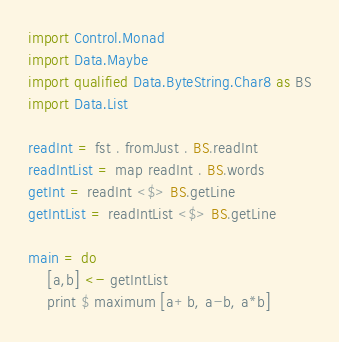<code> <loc_0><loc_0><loc_500><loc_500><_Haskell_>import Control.Monad
import Data.Maybe
import qualified Data.ByteString.Char8 as BS
import Data.List

readInt = fst . fromJust . BS.readInt
readIntList = map readInt . BS.words
getInt = readInt <$> BS.getLine
getIntList = readIntList <$> BS.getLine

main = do
    [a,b] <- getIntList
    print $ maximum [a+b, a-b, a*b]</code> 